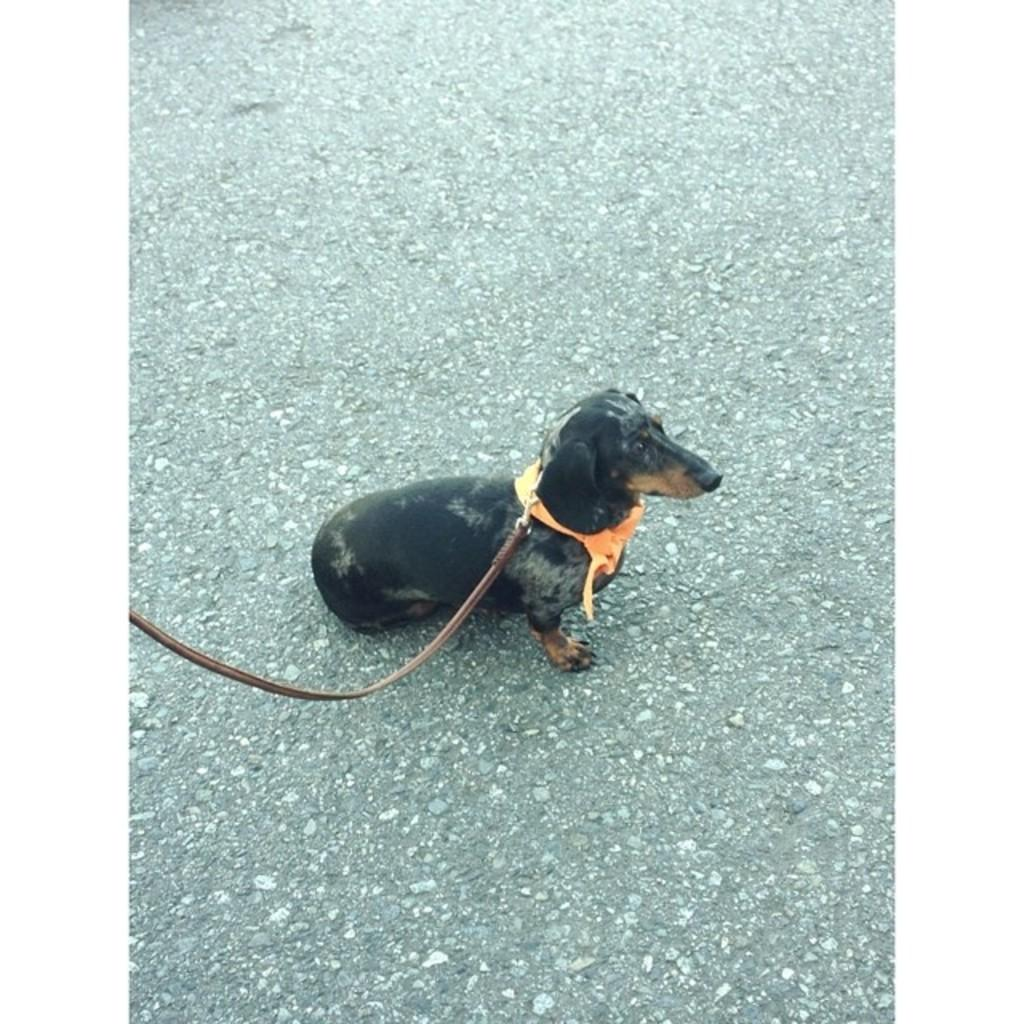What type of animal is present in the image? There is a dog in the image. What color is the dog? The dog is black in color. Where is the dog located in the image? The dog is sitting on the road. Is there any accessory or object attached to the dog? Yes, there is a belt tightened to the dog. What does the dog's aunt say about the dog's behavior in the image? There is no mention of an aunt or any dialogue in the image, so it is not possible to answer that question. 